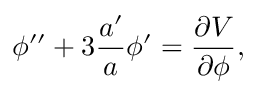Convert formula to latex. <formula><loc_0><loc_0><loc_500><loc_500>{ \phi } ^ { \prime \prime } + 3 \frac { a ^ { \prime } } { a } { \phi } ^ { \prime } = \frac { \partial V } { \partial \phi } ,</formula> 